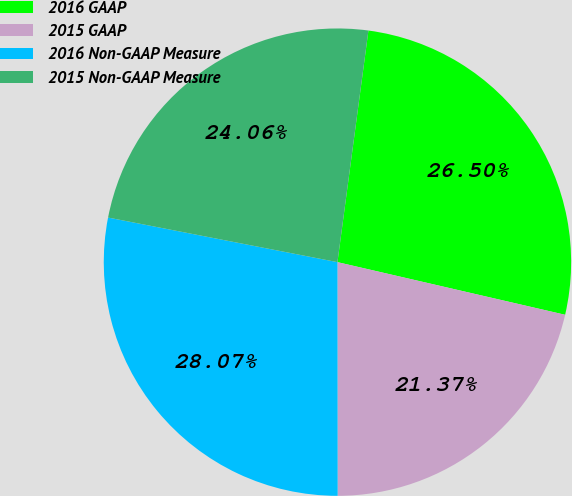Convert chart. <chart><loc_0><loc_0><loc_500><loc_500><pie_chart><fcel>2016 GAAP<fcel>2015 GAAP<fcel>2016 Non-GAAP Measure<fcel>2015 Non-GAAP Measure<nl><fcel>26.5%<fcel>21.37%<fcel>28.07%<fcel>24.06%<nl></chart> 